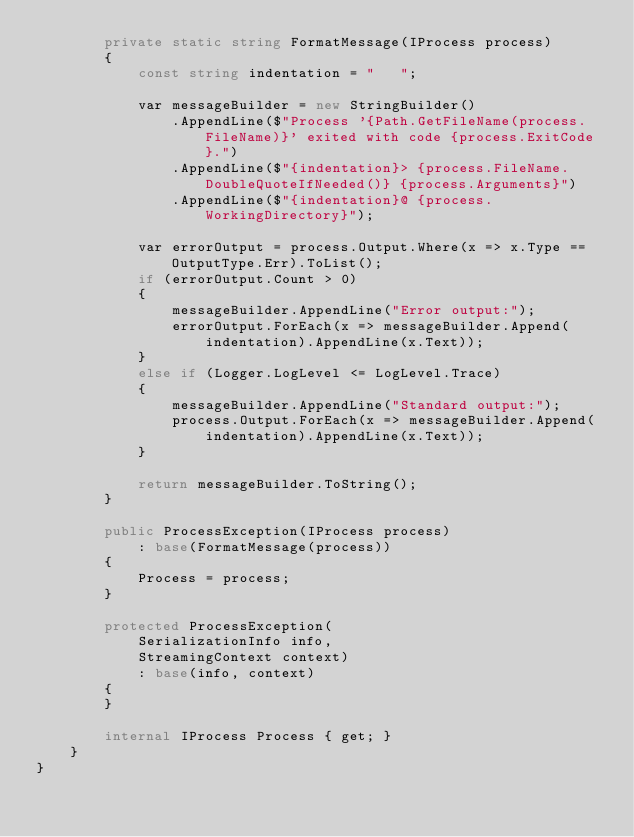Convert code to text. <code><loc_0><loc_0><loc_500><loc_500><_C#_>        private static string FormatMessage(IProcess process)
        {
            const string indentation = "   ";

            var messageBuilder = new StringBuilder()
                .AppendLine($"Process '{Path.GetFileName(process.FileName)}' exited with code {process.ExitCode}.")
                .AppendLine($"{indentation}> {process.FileName.DoubleQuoteIfNeeded()} {process.Arguments}")
                .AppendLine($"{indentation}@ {process.WorkingDirectory}");

            var errorOutput = process.Output.Where(x => x.Type == OutputType.Err).ToList();
            if (errorOutput.Count > 0)
            {
                messageBuilder.AppendLine("Error output:");
                errorOutput.ForEach(x => messageBuilder.Append(indentation).AppendLine(x.Text));
            }
            else if (Logger.LogLevel <= LogLevel.Trace)
            {
                messageBuilder.AppendLine("Standard output:");
                process.Output.ForEach(x => messageBuilder.Append(indentation).AppendLine(x.Text));
            }

            return messageBuilder.ToString();
        }

        public ProcessException(IProcess process)
            : base(FormatMessage(process))
        {
            Process = process;
        }

        protected ProcessException(
            SerializationInfo info,
            StreamingContext context)
            : base(info, context)
        {
        }

        internal IProcess Process { get; }
    }
}
</code> 